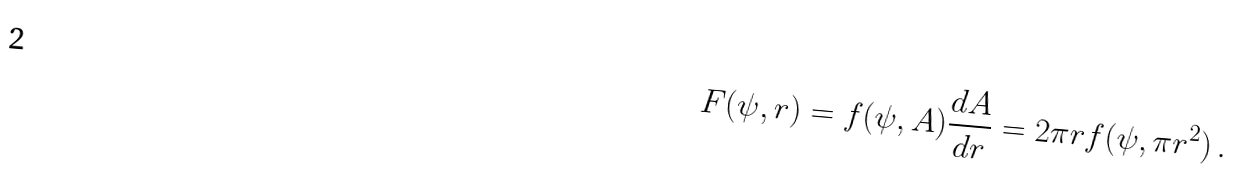<formula> <loc_0><loc_0><loc_500><loc_500>F ( \psi , r ) = f ( \psi , A ) \frac { d A } { d r } = 2 \pi r f ( \psi , \pi r ^ { 2 } ) \, .</formula> 